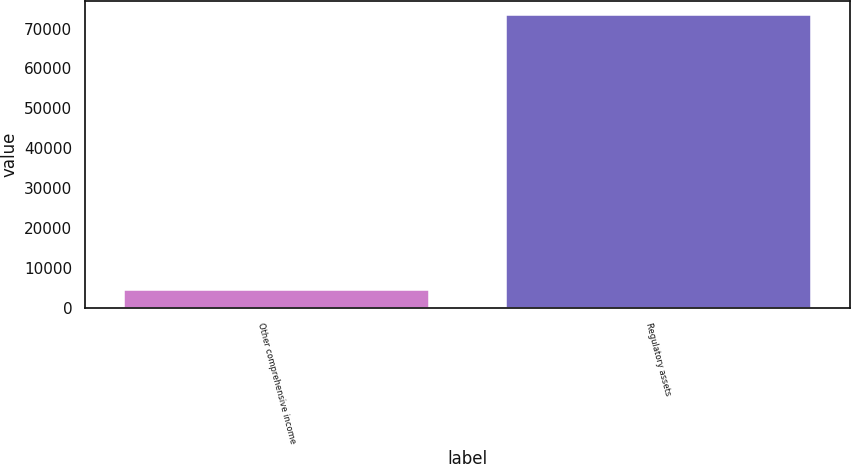Convert chart. <chart><loc_0><loc_0><loc_500><loc_500><bar_chart><fcel>Other comprehensive income<fcel>Regulatory assets<nl><fcel>4578<fcel>73311<nl></chart> 